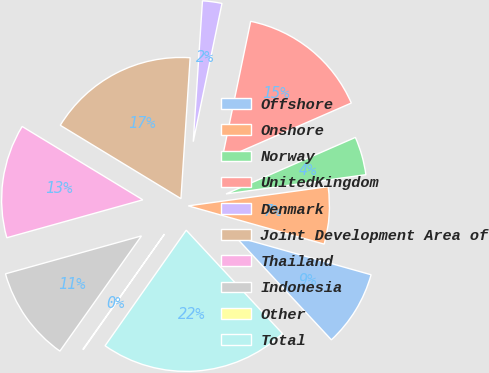<chart> <loc_0><loc_0><loc_500><loc_500><pie_chart><fcel>Offshore<fcel>Onshore<fcel>Norway<fcel>UnitedKingdom<fcel>Denmark<fcel>Joint Development Area of<fcel>Thailand<fcel>Indonesia<fcel>Other<fcel>Total<nl><fcel>8.7%<fcel>6.54%<fcel>4.38%<fcel>15.18%<fcel>2.22%<fcel>17.34%<fcel>13.02%<fcel>10.86%<fcel>0.06%<fcel>21.67%<nl></chart> 